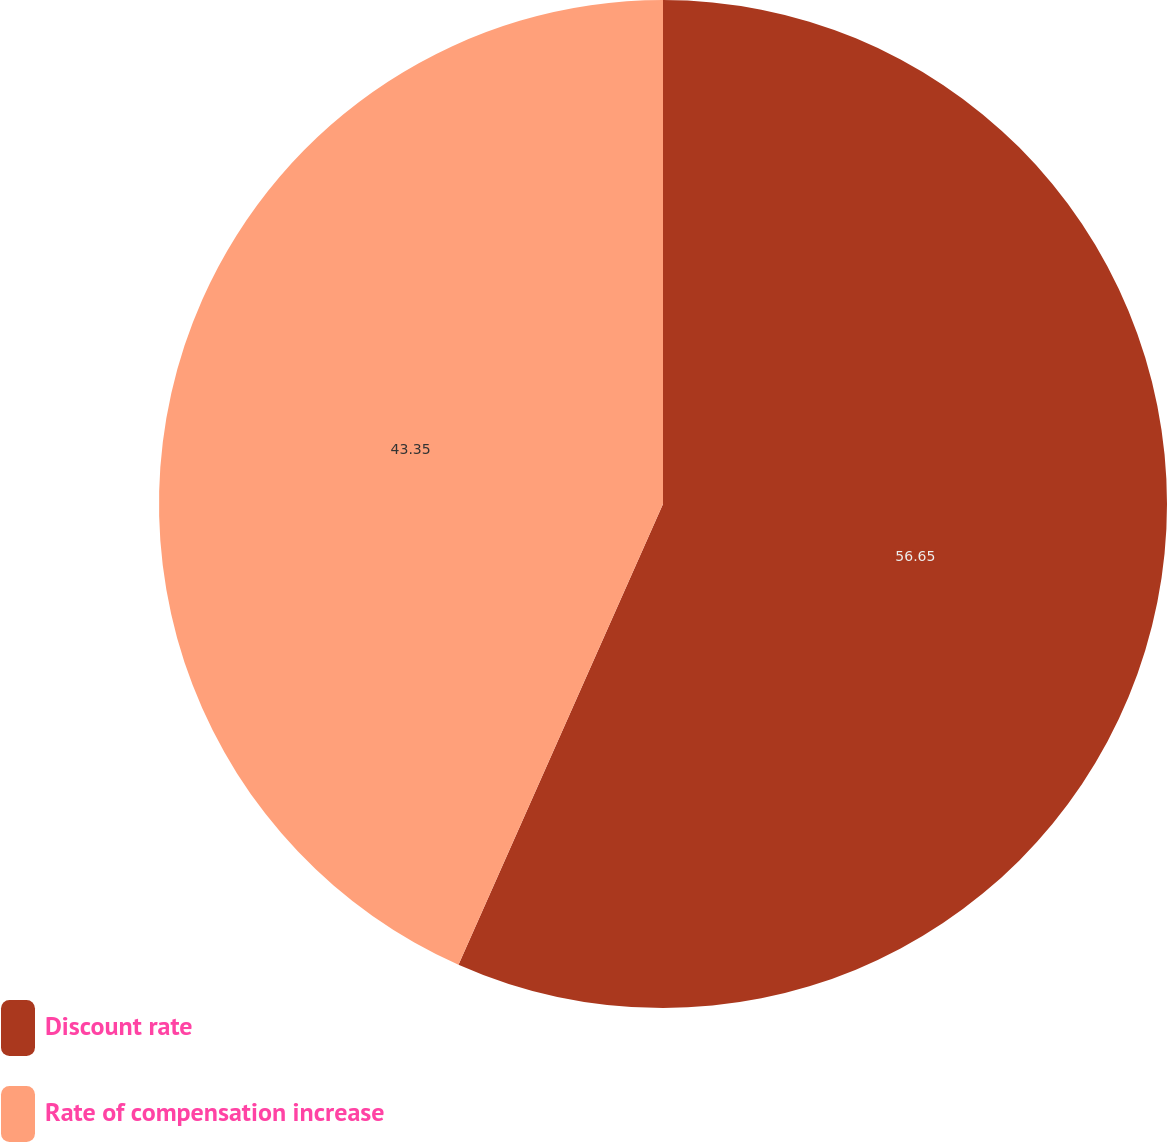<chart> <loc_0><loc_0><loc_500><loc_500><pie_chart><fcel>Discount rate<fcel>Rate of compensation increase<nl><fcel>56.65%<fcel>43.35%<nl></chart> 